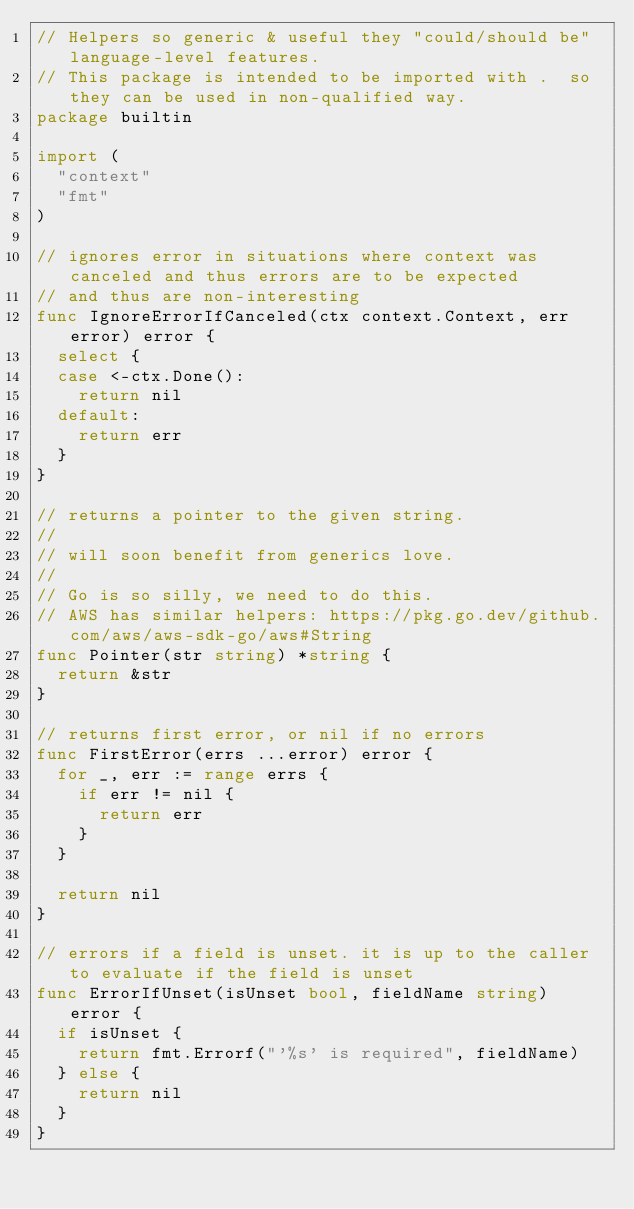<code> <loc_0><loc_0><loc_500><loc_500><_Go_>// Helpers so generic & useful they "could/should be" language-level features.
// This package is intended to be imported with .  so they can be used in non-qualified way.
package builtin

import (
	"context"
	"fmt"
)

// ignores error in situations where context was canceled and thus errors are to be expected
// and thus are non-interesting
func IgnoreErrorIfCanceled(ctx context.Context, err error) error {
	select {
	case <-ctx.Done():
		return nil
	default:
		return err
	}
}

// returns a pointer to the given string.
//
// will soon benefit from generics love.
//
// Go is so silly, we need to do this.
// AWS has similar helpers: https://pkg.go.dev/github.com/aws/aws-sdk-go/aws#String
func Pointer(str string) *string {
	return &str
}

// returns first error, or nil if no errors
func FirstError(errs ...error) error {
	for _, err := range errs {
		if err != nil {
			return err
		}
	}

	return nil
}

// errors if a field is unset. it is up to the caller to evaluate if the field is unset
func ErrorIfUnset(isUnset bool, fieldName string) error {
	if isUnset {
		return fmt.Errorf("'%s' is required", fieldName)
	} else {
		return nil
	}
}
</code> 